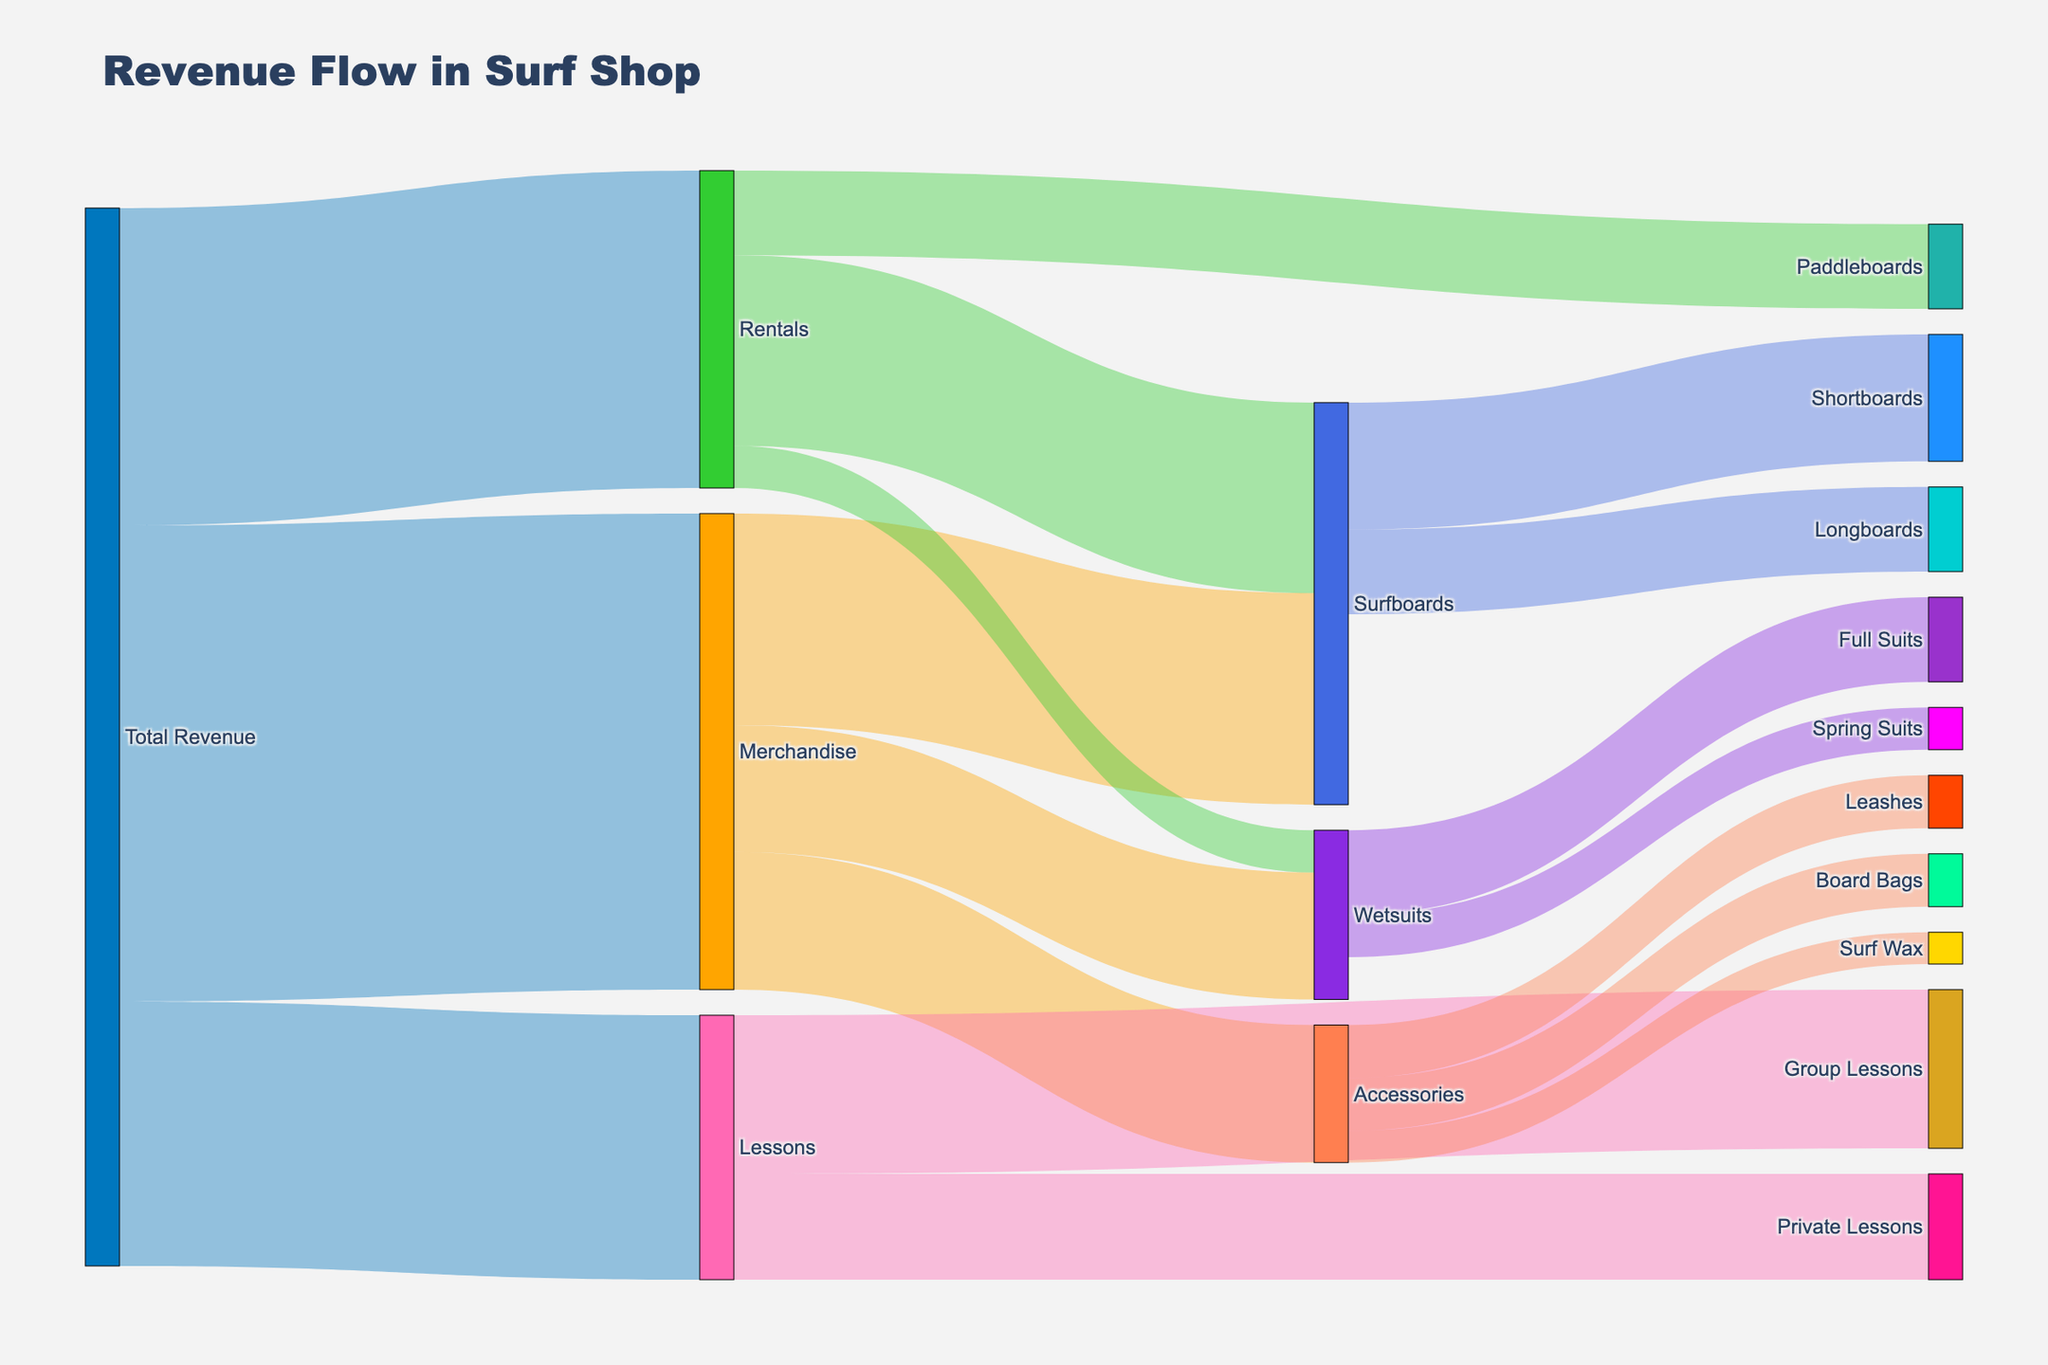What is the main source of revenue for the surf shop? The Sankey diagram shows that the main sources of revenue flow from "Total Revenue" to "Merchandise," "Rentals," and "Lessons." Among these, the largest flow in terms of value comes from "Merchandise" with a value of $45,000.
Answer: Merchandise Which category within "Merchandise" contributes the most to revenue? The diagram details the revenue flows within "Merchandise." The largest contribution comes from "Surfboards" with a value of $20,000.
Answer: Surfboards What is the total revenue generated from "Lessons" and "Rentals" combined? According to the diagram, "Lessons" generate $25,000 and "Rentals" generate $30,000. Their combined revenue is 25,000 + 30,000 = $55,000.
Answer: $55,000 Which sub-category within "Accessories" contributes the least to revenue? The diagram shows three sub-categories under "Accessories": "Surf Wax" ($3,000), "Leashes" ($5,000), and "Board Bags" ($5,000). "Surf Wax" contributes the least with $3,000.
Answer: Surf Wax How much more revenue do "Group Lessons" generate compared to "Private Lessons"? "Group Lessons" generate $15,000, while "Private Lessons" generate $10,000. The difference in revenue is 15,000 - 10,000 = $5,000.
Answer: $5,000 Which generates more revenue: "Shortboards" or "Longboards"? Within "Surfboards," the revenue from "Shortboards" is $12,000, and from "Longboards" it's $8,000. "Shortboards" generate more revenue.
Answer: Shortboards What percentage of the total "Merchandise" revenue comes from "Wetsuits"? "Merchandise" generates a total of $45,000, with "Wetsuits" contributing $12,000. The percentage is calculated by (12,000 / 45,000) * 100 = approximately 26.67%.
Answer: approximately 26.67% Does "Rentals" generate more revenue from "Paddleboards" or "Wetsuits"? The diagram shows "Paddleboards" generate $8,000 and "Wetsuits" generate $4,000 under "Rentals." "Paddleboards" generate more revenue.
Answer: Paddleboards What is the total revenue generated from "Wetsuits"? The diagram shows revenue under both "Merchandise" and "Rentals" categories. For "Merchandise," "Wetsuits" generate $12,000, and under "Rentals" they generate $4,000. The total revenue is 12,000 + 4,000 = $16,000.
Answer: $16,000 